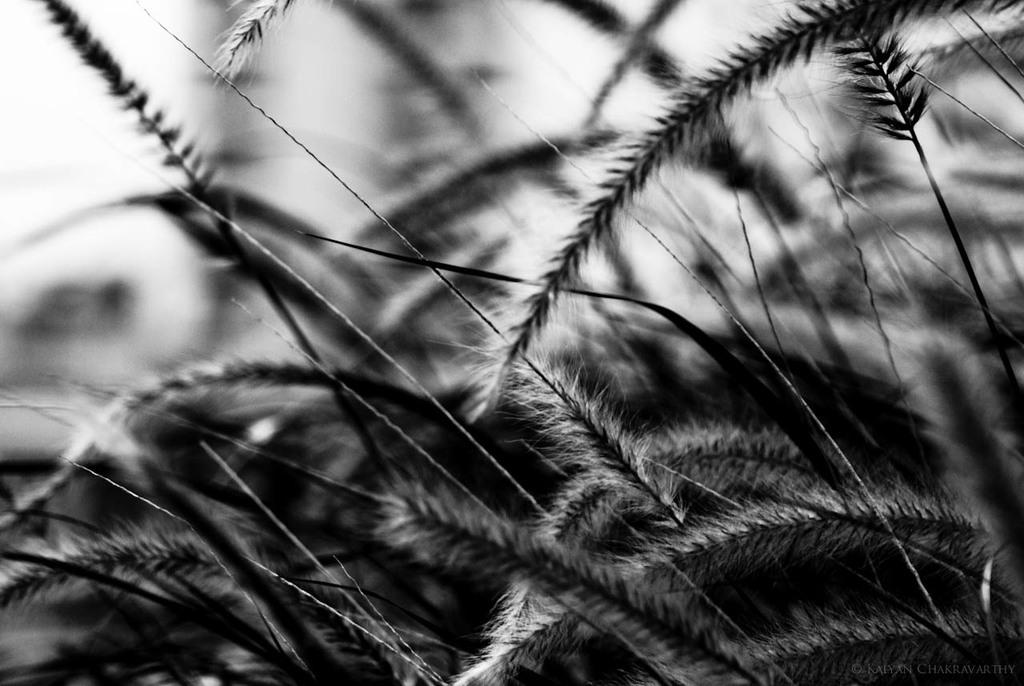What is the color scheme of the image? The image is black and white. What type of plants can be seen in the image? There are unwanted plants in the image. Can you describe the background of the image? The background of the image is blurry. What is the temper of the clam in the image? There is no clam present in the image, so it is not possible to determine its temper. 